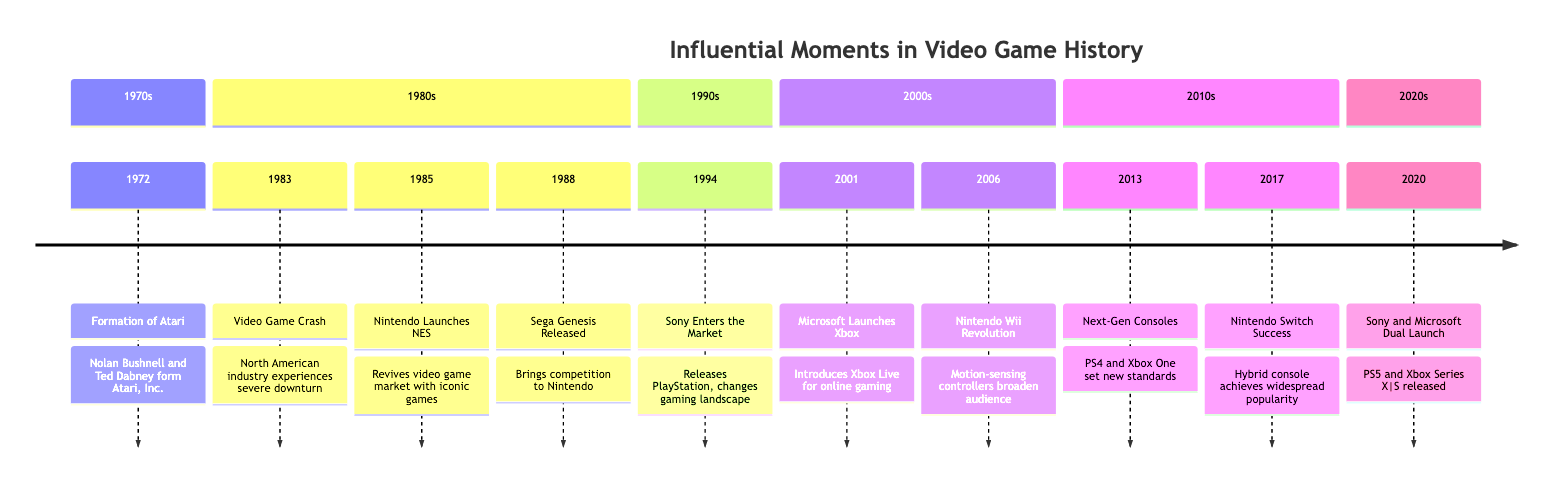What year was Atari formed? The diagram shows the formation of Atari in the year 1972. This is the earliest event in the timeline.
Answer: 1972 What event marked a downturn in the video game industry? According to the timeline, the event that marked a downturn in the industry was the "Video Game Crash," which occurred in 1983.
Answer: Video Game Crash Which console did Nintendo launch in 1985? The diagram indicates that in 1985, Nintendo launched the NES, also known as the Nintendo Entertainment System.
Answer: NES How many major console releases are noted in the 2000s? There are two major console releases noted in the 2000s: the Xbox launched in 2001 and the Wii released in 2006.
Answer: 2 What significant change did Sony introduce in 1994? In 1994, Sony introduced the PlayStation, which changed the landscape of video gaming with its 3D graphics and CD-based games, marking a significant change in gaming.
Answer: PlayStation Which company launched a hybrid console in 2017? The timeline states that in 2017, Nintendo launched the Switch, which is described as a hybrid console.
Answer: Nintendo In which decade did the Sega Genesis release? The Sega Genesis was released in 1988, which falls within the 1980s decade as shown on the timeline.
Answer: 1980s What aspect of gaming did the Nintendo Wii revolutionize? The timeline explains that the Nintendo Wii revolutionized gaming with its motion-sensing controllers, which broadened the audience.
Answer: Motion-sensing controllers 